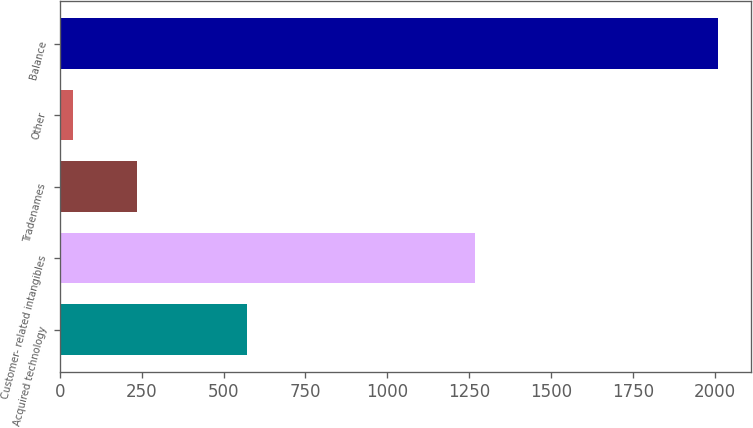Convert chart to OTSL. <chart><loc_0><loc_0><loc_500><loc_500><bar_chart><fcel>Acquired technology<fcel>Customer- related intangibles<fcel>Tradenames<fcel>Other<fcel>Balance<nl><fcel>572<fcel>1267<fcel>236.1<fcel>39<fcel>2010<nl></chart> 